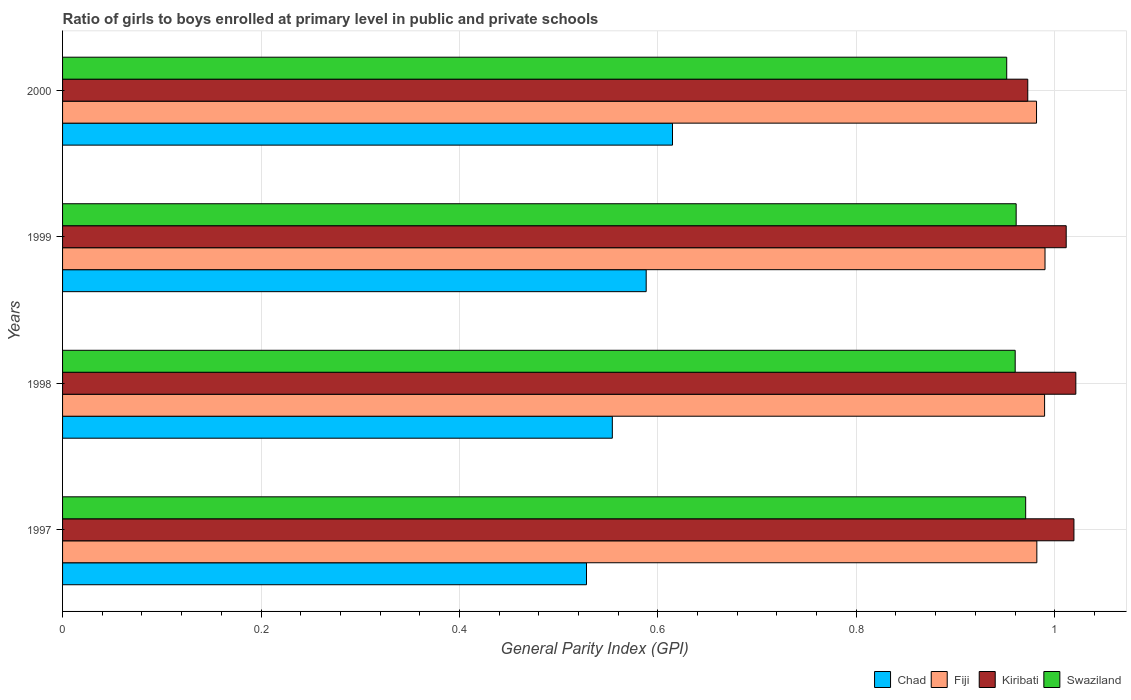How many different coloured bars are there?
Provide a succinct answer. 4. How many groups of bars are there?
Give a very brief answer. 4. How many bars are there on the 3rd tick from the bottom?
Offer a very short reply. 4. What is the label of the 4th group of bars from the top?
Your answer should be very brief. 1997. In how many cases, is the number of bars for a given year not equal to the number of legend labels?
Your answer should be very brief. 0. What is the general parity index in Chad in 1999?
Provide a short and direct response. 0.59. Across all years, what is the maximum general parity index in Swaziland?
Ensure brevity in your answer.  0.97. Across all years, what is the minimum general parity index in Fiji?
Keep it short and to the point. 0.98. In which year was the general parity index in Fiji minimum?
Your answer should be very brief. 2000. What is the total general parity index in Chad in the graph?
Give a very brief answer. 2.29. What is the difference between the general parity index in Kiribati in 1997 and that in 2000?
Provide a succinct answer. 0.05. What is the difference between the general parity index in Kiribati in 1998 and the general parity index in Fiji in 1999?
Make the answer very short. 0.03. What is the average general parity index in Kiribati per year?
Your answer should be very brief. 1.01. In the year 1999, what is the difference between the general parity index in Fiji and general parity index in Kiribati?
Offer a very short reply. -0.02. In how many years, is the general parity index in Kiribati greater than 0.04 ?
Ensure brevity in your answer.  4. What is the ratio of the general parity index in Kiribati in 1998 to that in 1999?
Your response must be concise. 1.01. Is the general parity index in Chad in 1998 less than that in 2000?
Ensure brevity in your answer.  Yes. Is the difference between the general parity index in Fiji in 1997 and 1999 greater than the difference between the general parity index in Kiribati in 1997 and 1999?
Provide a succinct answer. No. What is the difference between the highest and the second highest general parity index in Chad?
Ensure brevity in your answer.  0.03. What is the difference between the highest and the lowest general parity index in Fiji?
Provide a succinct answer. 0.01. In how many years, is the general parity index in Kiribati greater than the average general parity index in Kiribati taken over all years?
Ensure brevity in your answer.  3. Is the sum of the general parity index in Fiji in 1997 and 1998 greater than the maximum general parity index in Swaziland across all years?
Keep it short and to the point. Yes. What does the 1st bar from the top in 1997 represents?
Offer a very short reply. Swaziland. What does the 4th bar from the bottom in 1997 represents?
Make the answer very short. Swaziland. Is it the case that in every year, the sum of the general parity index in Fiji and general parity index in Chad is greater than the general parity index in Kiribati?
Make the answer very short. Yes. How many bars are there?
Make the answer very short. 16. Are the values on the major ticks of X-axis written in scientific E-notation?
Keep it short and to the point. No. Does the graph contain grids?
Offer a terse response. Yes. How many legend labels are there?
Give a very brief answer. 4. What is the title of the graph?
Your response must be concise. Ratio of girls to boys enrolled at primary level in public and private schools. Does "Arab World" appear as one of the legend labels in the graph?
Provide a short and direct response. No. What is the label or title of the X-axis?
Keep it short and to the point. General Parity Index (GPI). What is the label or title of the Y-axis?
Your answer should be compact. Years. What is the General Parity Index (GPI) of Chad in 1997?
Your answer should be very brief. 0.53. What is the General Parity Index (GPI) of Fiji in 1997?
Ensure brevity in your answer.  0.98. What is the General Parity Index (GPI) of Kiribati in 1997?
Provide a short and direct response. 1.02. What is the General Parity Index (GPI) of Swaziland in 1997?
Offer a very short reply. 0.97. What is the General Parity Index (GPI) in Chad in 1998?
Ensure brevity in your answer.  0.55. What is the General Parity Index (GPI) of Fiji in 1998?
Your response must be concise. 0.99. What is the General Parity Index (GPI) of Kiribati in 1998?
Provide a succinct answer. 1.02. What is the General Parity Index (GPI) of Swaziland in 1998?
Give a very brief answer. 0.96. What is the General Parity Index (GPI) in Chad in 1999?
Give a very brief answer. 0.59. What is the General Parity Index (GPI) in Fiji in 1999?
Make the answer very short. 0.99. What is the General Parity Index (GPI) of Kiribati in 1999?
Provide a short and direct response. 1.01. What is the General Parity Index (GPI) of Swaziland in 1999?
Provide a succinct answer. 0.96. What is the General Parity Index (GPI) of Chad in 2000?
Your answer should be compact. 0.61. What is the General Parity Index (GPI) in Fiji in 2000?
Offer a very short reply. 0.98. What is the General Parity Index (GPI) in Kiribati in 2000?
Ensure brevity in your answer.  0.97. What is the General Parity Index (GPI) in Swaziland in 2000?
Your answer should be very brief. 0.95. Across all years, what is the maximum General Parity Index (GPI) in Chad?
Your answer should be very brief. 0.61. Across all years, what is the maximum General Parity Index (GPI) of Fiji?
Provide a succinct answer. 0.99. Across all years, what is the maximum General Parity Index (GPI) in Kiribati?
Provide a succinct answer. 1.02. Across all years, what is the maximum General Parity Index (GPI) of Swaziland?
Provide a short and direct response. 0.97. Across all years, what is the minimum General Parity Index (GPI) in Chad?
Keep it short and to the point. 0.53. Across all years, what is the minimum General Parity Index (GPI) in Fiji?
Your answer should be very brief. 0.98. Across all years, what is the minimum General Parity Index (GPI) in Kiribati?
Make the answer very short. 0.97. Across all years, what is the minimum General Parity Index (GPI) in Swaziland?
Provide a short and direct response. 0.95. What is the total General Parity Index (GPI) in Chad in the graph?
Provide a succinct answer. 2.29. What is the total General Parity Index (GPI) in Fiji in the graph?
Your response must be concise. 3.94. What is the total General Parity Index (GPI) of Kiribati in the graph?
Your answer should be compact. 4.03. What is the total General Parity Index (GPI) in Swaziland in the graph?
Provide a short and direct response. 3.84. What is the difference between the General Parity Index (GPI) of Chad in 1997 and that in 1998?
Offer a terse response. -0.03. What is the difference between the General Parity Index (GPI) in Fiji in 1997 and that in 1998?
Give a very brief answer. -0.01. What is the difference between the General Parity Index (GPI) in Kiribati in 1997 and that in 1998?
Provide a succinct answer. -0. What is the difference between the General Parity Index (GPI) in Swaziland in 1997 and that in 1998?
Provide a short and direct response. 0.01. What is the difference between the General Parity Index (GPI) of Chad in 1997 and that in 1999?
Your answer should be compact. -0.06. What is the difference between the General Parity Index (GPI) in Fiji in 1997 and that in 1999?
Provide a short and direct response. -0.01. What is the difference between the General Parity Index (GPI) in Kiribati in 1997 and that in 1999?
Provide a succinct answer. 0.01. What is the difference between the General Parity Index (GPI) of Swaziland in 1997 and that in 1999?
Offer a terse response. 0.01. What is the difference between the General Parity Index (GPI) in Chad in 1997 and that in 2000?
Ensure brevity in your answer.  -0.09. What is the difference between the General Parity Index (GPI) in Fiji in 1997 and that in 2000?
Give a very brief answer. 0. What is the difference between the General Parity Index (GPI) of Kiribati in 1997 and that in 2000?
Provide a short and direct response. 0.05. What is the difference between the General Parity Index (GPI) in Swaziland in 1997 and that in 2000?
Provide a short and direct response. 0.02. What is the difference between the General Parity Index (GPI) of Chad in 1998 and that in 1999?
Offer a very short reply. -0.03. What is the difference between the General Parity Index (GPI) of Fiji in 1998 and that in 1999?
Offer a very short reply. -0. What is the difference between the General Parity Index (GPI) in Kiribati in 1998 and that in 1999?
Ensure brevity in your answer.  0.01. What is the difference between the General Parity Index (GPI) in Swaziland in 1998 and that in 1999?
Offer a terse response. -0. What is the difference between the General Parity Index (GPI) of Chad in 1998 and that in 2000?
Make the answer very short. -0.06. What is the difference between the General Parity Index (GPI) of Fiji in 1998 and that in 2000?
Provide a succinct answer. 0.01. What is the difference between the General Parity Index (GPI) in Kiribati in 1998 and that in 2000?
Offer a very short reply. 0.05. What is the difference between the General Parity Index (GPI) of Swaziland in 1998 and that in 2000?
Your response must be concise. 0.01. What is the difference between the General Parity Index (GPI) of Chad in 1999 and that in 2000?
Ensure brevity in your answer.  -0.03. What is the difference between the General Parity Index (GPI) in Fiji in 1999 and that in 2000?
Your response must be concise. 0.01. What is the difference between the General Parity Index (GPI) in Kiribati in 1999 and that in 2000?
Keep it short and to the point. 0.04. What is the difference between the General Parity Index (GPI) of Swaziland in 1999 and that in 2000?
Give a very brief answer. 0.01. What is the difference between the General Parity Index (GPI) of Chad in 1997 and the General Parity Index (GPI) of Fiji in 1998?
Offer a very short reply. -0.46. What is the difference between the General Parity Index (GPI) of Chad in 1997 and the General Parity Index (GPI) of Kiribati in 1998?
Make the answer very short. -0.49. What is the difference between the General Parity Index (GPI) in Chad in 1997 and the General Parity Index (GPI) in Swaziland in 1998?
Make the answer very short. -0.43. What is the difference between the General Parity Index (GPI) in Fiji in 1997 and the General Parity Index (GPI) in Kiribati in 1998?
Make the answer very short. -0.04. What is the difference between the General Parity Index (GPI) of Fiji in 1997 and the General Parity Index (GPI) of Swaziland in 1998?
Offer a terse response. 0.02. What is the difference between the General Parity Index (GPI) of Kiribati in 1997 and the General Parity Index (GPI) of Swaziland in 1998?
Provide a succinct answer. 0.06. What is the difference between the General Parity Index (GPI) in Chad in 1997 and the General Parity Index (GPI) in Fiji in 1999?
Your answer should be compact. -0.46. What is the difference between the General Parity Index (GPI) of Chad in 1997 and the General Parity Index (GPI) of Kiribati in 1999?
Ensure brevity in your answer.  -0.48. What is the difference between the General Parity Index (GPI) of Chad in 1997 and the General Parity Index (GPI) of Swaziland in 1999?
Your answer should be very brief. -0.43. What is the difference between the General Parity Index (GPI) in Fiji in 1997 and the General Parity Index (GPI) in Kiribati in 1999?
Offer a terse response. -0.03. What is the difference between the General Parity Index (GPI) of Fiji in 1997 and the General Parity Index (GPI) of Swaziland in 1999?
Keep it short and to the point. 0.02. What is the difference between the General Parity Index (GPI) in Kiribati in 1997 and the General Parity Index (GPI) in Swaziland in 1999?
Make the answer very short. 0.06. What is the difference between the General Parity Index (GPI) of Chad in 1997 and the General Parity Index (GPI) of Fiji in 2000?
Provide a short and direct response. -0.45. What is the difference between the General Parity Index (GPI) of Chad in 1997 and the General Parity Index (GPI) of Kiribati in 2000?
Provide a succinct answer. -0.44. What is the difference between the General Parity Index (GPI) in Chad in 1997 and the General Parity Index (GPI) in Swaziland in 2000?
Keep it short and to the point. -0.42. What is the difference between the General Parity Index (GPI) of Fiji in 1997 and the General Parity Index (GPI) of Kiribati in 2000?
Offer a very short reply. 0.01. What is the difference between the General Parity Index (GPI) of Fiji in 1997 and the General Parity Index (GPI) of Swaziland in 2000?
Provide a short and direct response. 0.03. What is the difference between the General Parity Index (GPI) of Kiribati in 1997 and the General Parity Index (GPI) of Swaziland in 2000?
Your response must be concise. 0.07. What is the difference between the General Parity Index (GPI) in Chad in 1998 and the General Parity Index (GPI) in Fiji in 1999?
Keep it short and to the point. -0.44. What is the difference between the General Parity Index (GPI) of Chad in 1998 and the General Parity Index (GPI) of Kiribati in 1999?
Offer a very short reply. -0.46. What is the difference between the General Parity Index (GPI) in Chad in 1998 and the General Parity Index (GPI) in Swaziland in 1999?
Offer a very short reply. -0.41. What is the difference between the General Parity Index (GPI) of Fiji in 1998 and the General Parity Index (GPI) of Kiribati in 1999?
Your answer should be compact. -0.02. What is the difference between the General Parity Index (GPI) in Fiji in 1998 and the General Parity Index (GPI) in Swaziland in 1999?
Keep it short and to the point. 0.03. What is the difference between the General Parity Index (GPI) in Kiribati in 1998 and the General Parity Index (GPI) in Swaziland in 1999?
Ensure brevity in your answer.  0.06. What is the difference between the General Parity Index (GPI) of Chad in 1998 and the General Parity Index (GPI) of Fiji in 2000?
Offer a very short reply. -0.43. What is the difference between the General Parity Index (GPI) of Chad in 1998 and the General Parity Index (GPI) of Kiribati in 2000?
Your response must be concise. -0.42. What is the difference between the General Parity Index (GPI) in Chad in 1998 and the General Parity Index (GPI) in Swaziland in 2000?
Your answer should be compact. -0.4. What is the difference between the General Parity Index (GPI) in Fiji in 1998 and the General Parity Index (GPI) in Kiribati in 2000?
Provide a succinct answer. 0.02. What is the difference between the General Parity Index (GPI) in Fiji in 1998 and the General Parity Index (GPI) in Swaziland in 2000?
Your answer should be compact. 0.04. What is the difference between the General Parity Index (GPI) in Kiribati in 1998 and the General Parity Index (GPI) in Swaziland in 2000?
Give a very brief answer. 0.07. What is the difference between the General Parity Index (GPI) of Chad in 1999 and the General Parity Index (GPI) of Fiji in 2000?
Ensure brevity in your answer.  -0.39. What is the difference between the General Parity Index (GPI) in Chad in 1999 and the General Parity Index (GPI) in Kiribati in 2000?
Provide a short and direct response. -0.38. What is the difference between the General Parity Index (GPI) of Chad in 1999 and the General Parity Index (GPI) of Swaziland in 2000?
Make the answer very short. -0.36. What is the difference between the General Parity Index (GPI) of Fiji in 1999 and the General Parity Index (GPI) of Kiribati in 2000?
Your response must be concise. 0.02. What is the difference between the General Parity Index (GPI) of Fiji in 1999 and the General Parity Index (GPI) of Swaziland in 2000?
Your answer should be very brief. 0.04. What is the difference between the General Parity Index (GPI) in Kiribati in 1999 and the General Parity Index (GPI) in Swaziland in 2000?
Your response must be concise. 0.06. What is the average General Parity Index (GPI) in Chad per year?
Make the answer very short. 0.57. What is the average General Parity Index (GPI) of Fiji per year?
Offer a terse response. 0.99. What is the average General Parity Index (GPI) of Kiribati per year?
Offer a terse response. 1.01. What is the average General Parity Index (GPI) in Swaziland per year?
Ensure brevity in your answer.  0.96. In the year 1997, what is the difference between the General Parity Index (GPI) in Chad and General Parity Index (GPI) in Fiji?
Make the answer very short. -0.45. In the year 1997, what is the difference between the General Parity Index (GPI) of Chad and General Parity Index (GPI) of Kiribati?
Offer a terse response. -0.49. In the year 1997, what is the difference between the General Parity Index (GPI) of Chad and General Parity Index (GPI) of Swaziland?
Make the answer very short. -0.44. In the year 1997, what is the difference between the General Parity Index (GPI) in Fiji and General Parity Index (GPI) in Kiribati?
Offer a terse response. -0.04. In the year 1997, what is the difference between the General Parity Index (GPI) in Fiji and General Parity Index (GPI) in Swaziland?
Offer a terse response. 0.01. In the year 1997, what is the difference between the General Parity Index (GPI) in Kiribati and General Parity Index (GPI) in Swaziland?
Give a very brief answer. 0.05. In the year 1998, what is the difference between the General Parity Index (GPI) in Chad and General Parity Index (GPI) in Fiji?
Keep it short and to the point. -0.44. In the year 1998, what is the difference between the General Parity Index (GPI) in Chad and General Parity Index (GPI) in Kiribati?
Provide a succinct answer. -0.47. In the year 1998, what is the difference between the General Parity Index (GPI) of Chad and General Parity Index (GPI) of Swaziland?
Ensure brevity in your answer.  -0.41. In the year 1998, what is the difference between the General Parity Index (GPI) in Fiji and General Parity Index (GPI) in Kiribati?
Provide a short and direct response. -0.03. In the year 1998, what is the difference between the General Parity Index (GPI) in Fiji and General Parity Index (GPI) in Swaziland?
Keep it short and to the point. 0.03. In the year 1998, what is the difference between the General Parity Index (GPI) of Kiribati and General Parity Index (GPI) of Swaziland?
Your response must be concise. 0.06. In the year 1999, what is the difference between the General Parity Index (GPI) of Chad and General Parity Index (GPI) of Fiji?
Make the answer very short. -0.4. In the year 1999, what is the difference between the General Parity Index (GPI) in Chad and General Parity Index (GPI) in Kiribati?
Ensure brevity in your answer.  -0.42. In the year 1999, what is the difference between the General Parity Index (GPI) in Chad and General Parity Index (GPI) in Swaziland?
Offer a very short reply. -0.37. In the year 1999, what is the difference between the General Parity Index (GPI) of Fiji and General Parity Index (GPI) of Kiribati?
Your answer should be very brief. -0.02. In the year 1999, what is the difference between the General Parity Index (GPI) of Fiji and General Parity Index (GPI) of Swaziland?
Provide a short and direct response. 0.03. In the year 1999, what is the difference between the General Parity Index (GPI) of Kiribati and General Parity Index (GPI) of Swaziland?
Keep it short and to the point. 0.05. In the year 2000, what is the difference between the General Parity Index (GPI) of Chad and General Parity Index (GPI) of Fiji?
Ensure brevity in your answer.  -0.37. In the year 2000, what is the difference between the General Parity Index (GPI) in Chad and General Parity Index (GPI) in Kiribati?
Your answer should be compact. -0.36. In the year 2000, what is the difference between the General Parity Index (GPI) of Chad and General Parity Index (GPI) of Swaziland?
Offer a terse response. -0.34. In the year 2000, what is the difference between the General Parity Index (GPI) in Fiji and General Parity Index (GPI) in Kiribati?
Keep it short and to the point. 0.01. In the year 2000, what is the difference between the General Parity Index (GPI) of Kiribati and General Parity Index (GPI) of Swaziland?
Provide a succinct answer. 0.02. What is the ratio of the General Parity Index (GPI) of Chad in 1997 to that in 1998?
Your answer should be compact. 0.95. What is the ratio of the General Parity Index (GPI) of Fiji in 1997 to that in 1998?
Ensure brevity in your answer.  0.99. What is the ratio of the General Parity Index (GPI) in Kiribati in 1997 to that in 1998?
Your response must be concise. 1. What is the ratio of the General Parity Index (GPI) of Chad in 1997 to that in 1999?
Your response must be concise. 0.9. What is the ratio of the General Parity Index (GPI) in Fiji in 1997 to that in 1999?
Offer a terse response. 0.99. What is the ratio of the General Parity Index (GPI) of Kiribati in 1997 to that in 1999?
Provide a short and direct response. 1.01. What is the ratio of the General Parity Index (GPI) of Chad in 1997 to that in 2000?
Give a very brief answer. 0.86. What is the ratio of the General Parity Index (GPI) of Kiribati in 1997 to that in 2000?
Provide a short and direct response. 1.05. What is the ratio of the General Parity Index (GPI) in Swaziland in 1997 to that in 2000?
Give a very brief answer. 1.02. What is the ratio of the General Parity Index (GPI) of Chad in 1998 to that in 1999?
Ensure brevity in your answer.  0.94. What is the ratio of the General Parity Index (GPI) in Fiji in 1998 to that in 1999?
Your response must be concise. 1. What is the ratio of the General Parity Index (GPI) of Kiribati in 1998 to that in 1999?
Your answer should be very brief. 1.01. What is the ratio of the General Parity Index (GPI) of Chad in 1998 to that in 2000?
Your answer should be very brief. 0.9. What is the ratio of the General Parity Index (GPI) in Fiji in 1998 to that in 2000?
Give a very brief answer. 1.01. What is the ratio of the General Parity Index (GPI) of Kiribati in 1998 to that in 2000?
Your answer should be compact. 1.05. What is the ratio of the General Parity Index (GPI) of Chad in 1999 to that in 2000?
Your answer should be compact. 0.96. What is the ratio of the General Parity Index (GPI) in Fiji in 1999 to that in 2000?
Provide a short and direct response. 1.01. What is the ratio of the General Parity Index (GPI) of Kiribati in 1999 to that in 2000?
Provide a succinct answer. 1.04. What is the ratio of the General Parity Index (GPI) in Swaziland in 1999 to that in 2000?
Offer a terse response. 1.01. What is the difference between the highest and the second highest General Parity Index (GPI) in Chad?
Ensure brevity in your answer.  0.03. What is the difference between the highest and the second highest General Parity Index (GPI) in Kiribati?
Your answer should be compact. 0. What is the difference between the highest and the second highest General Parity Index (GPI) of Swaziland?
Keep it short and to the point. 0.01. What is the difference between the highest and the lowest General Parity Index (GPI) of Chad?
Offer a terse response. 0.09. What is the difference between the highest and the lowest General Parity Index (GPI) in Fiji?
Your answer should be compact. 0.01. What is the difference between the highest and the lowest General Parity Index (GPI) in Kiribati?
Your response must be concise. 0.05. What is the difference between the highest and the lowest General Parity Index (GPI) in Swaziland?
Your answer should be very brief. 0.02. 